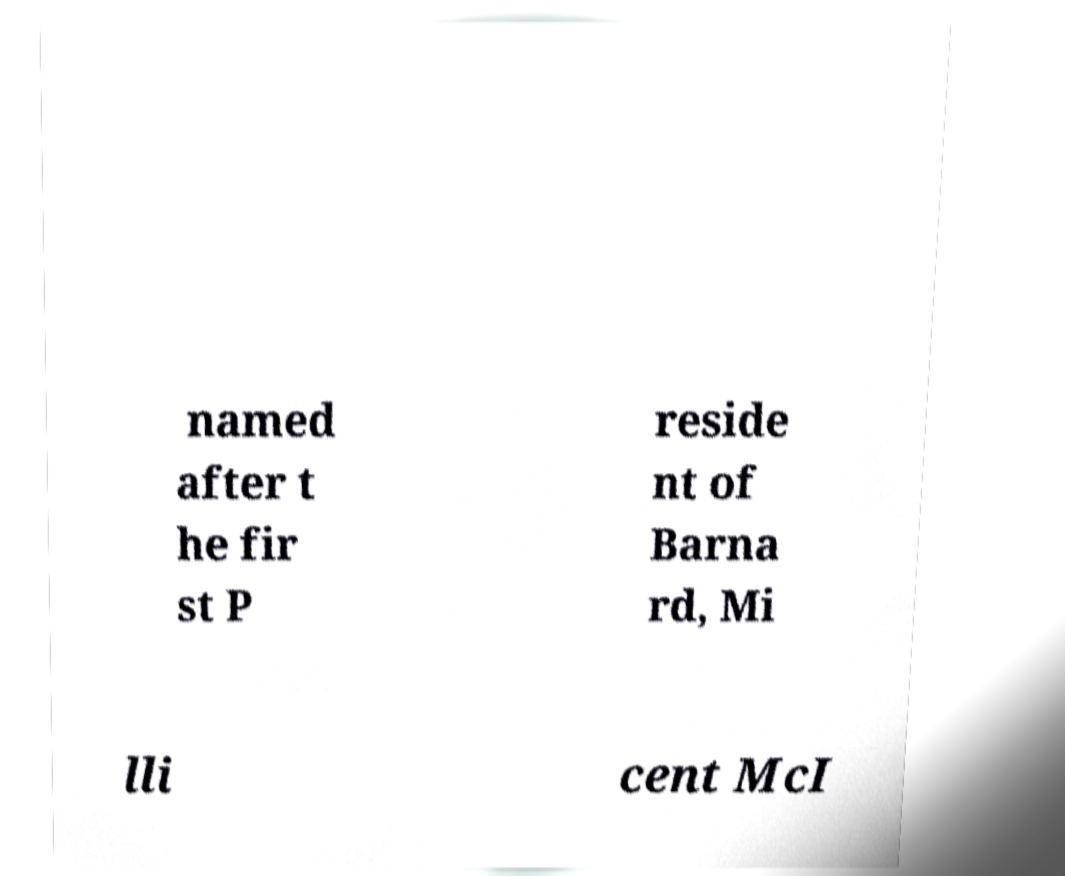Could you assist in decoding the text presented in this image and type it out clearly? named after t he fir st P reside nt of Barna rd, Mi lli cent McI 